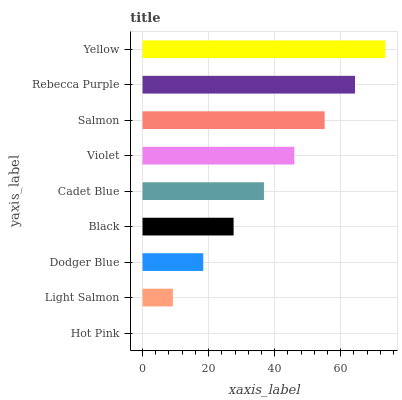Is Hot Pink the minimum?
Answer yes or no. Yes. Is Yellow the maximum?
Answer yes or no. Yes. Is Light Salmon the minimum?
Answer yes or no. No. Is Light Salmon the maximum?
Answer yes or no. No. Is Light Salmon greater than Hot Pink?
Answer yes or no. Yes. Is Hot Pink less than Light Salmon?
Answer yes or no. Yes. Is Hot Pink greater than Light Salmon?
Answer yes or no. No. Is Light Salmon less than Hot Pink?
Answer yes or no. No. Is Cadet Blue the high median?
Answer yes or no. Yes. Is Cadet Blue the low median?
Answer yes or no. Yes. Is Dodger Blue the high median?
Answer yes or no. No. Is Dodger Blue the low median?
Answer yes or no. No. 